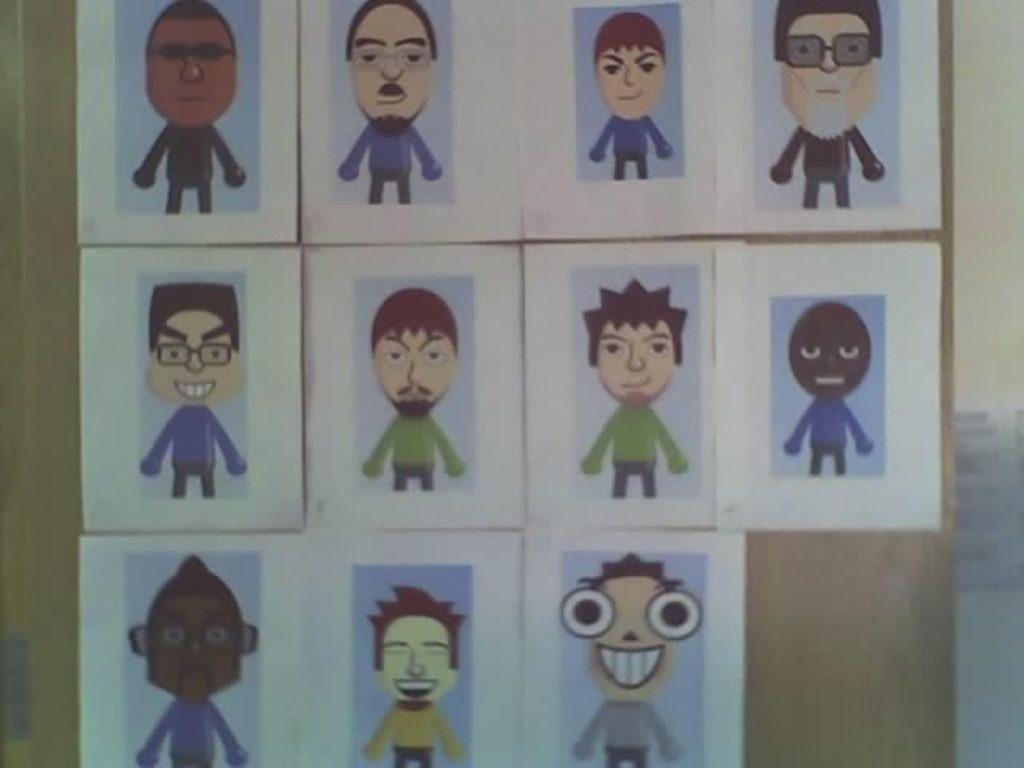What is the main subject of the image? The main subject of the image is a group of pictures. How are the pictures arranged in the image? The pictures are pasted on a surface. Can you tell me how many uncles are depicted in the pictures? There is no information about uncles or any specific people in the pictures, as the facts only mention a group of pictures. What type of toad can be seen in the image? There is no toad present in the image; it only features a group of pictures pasted on a surface. 